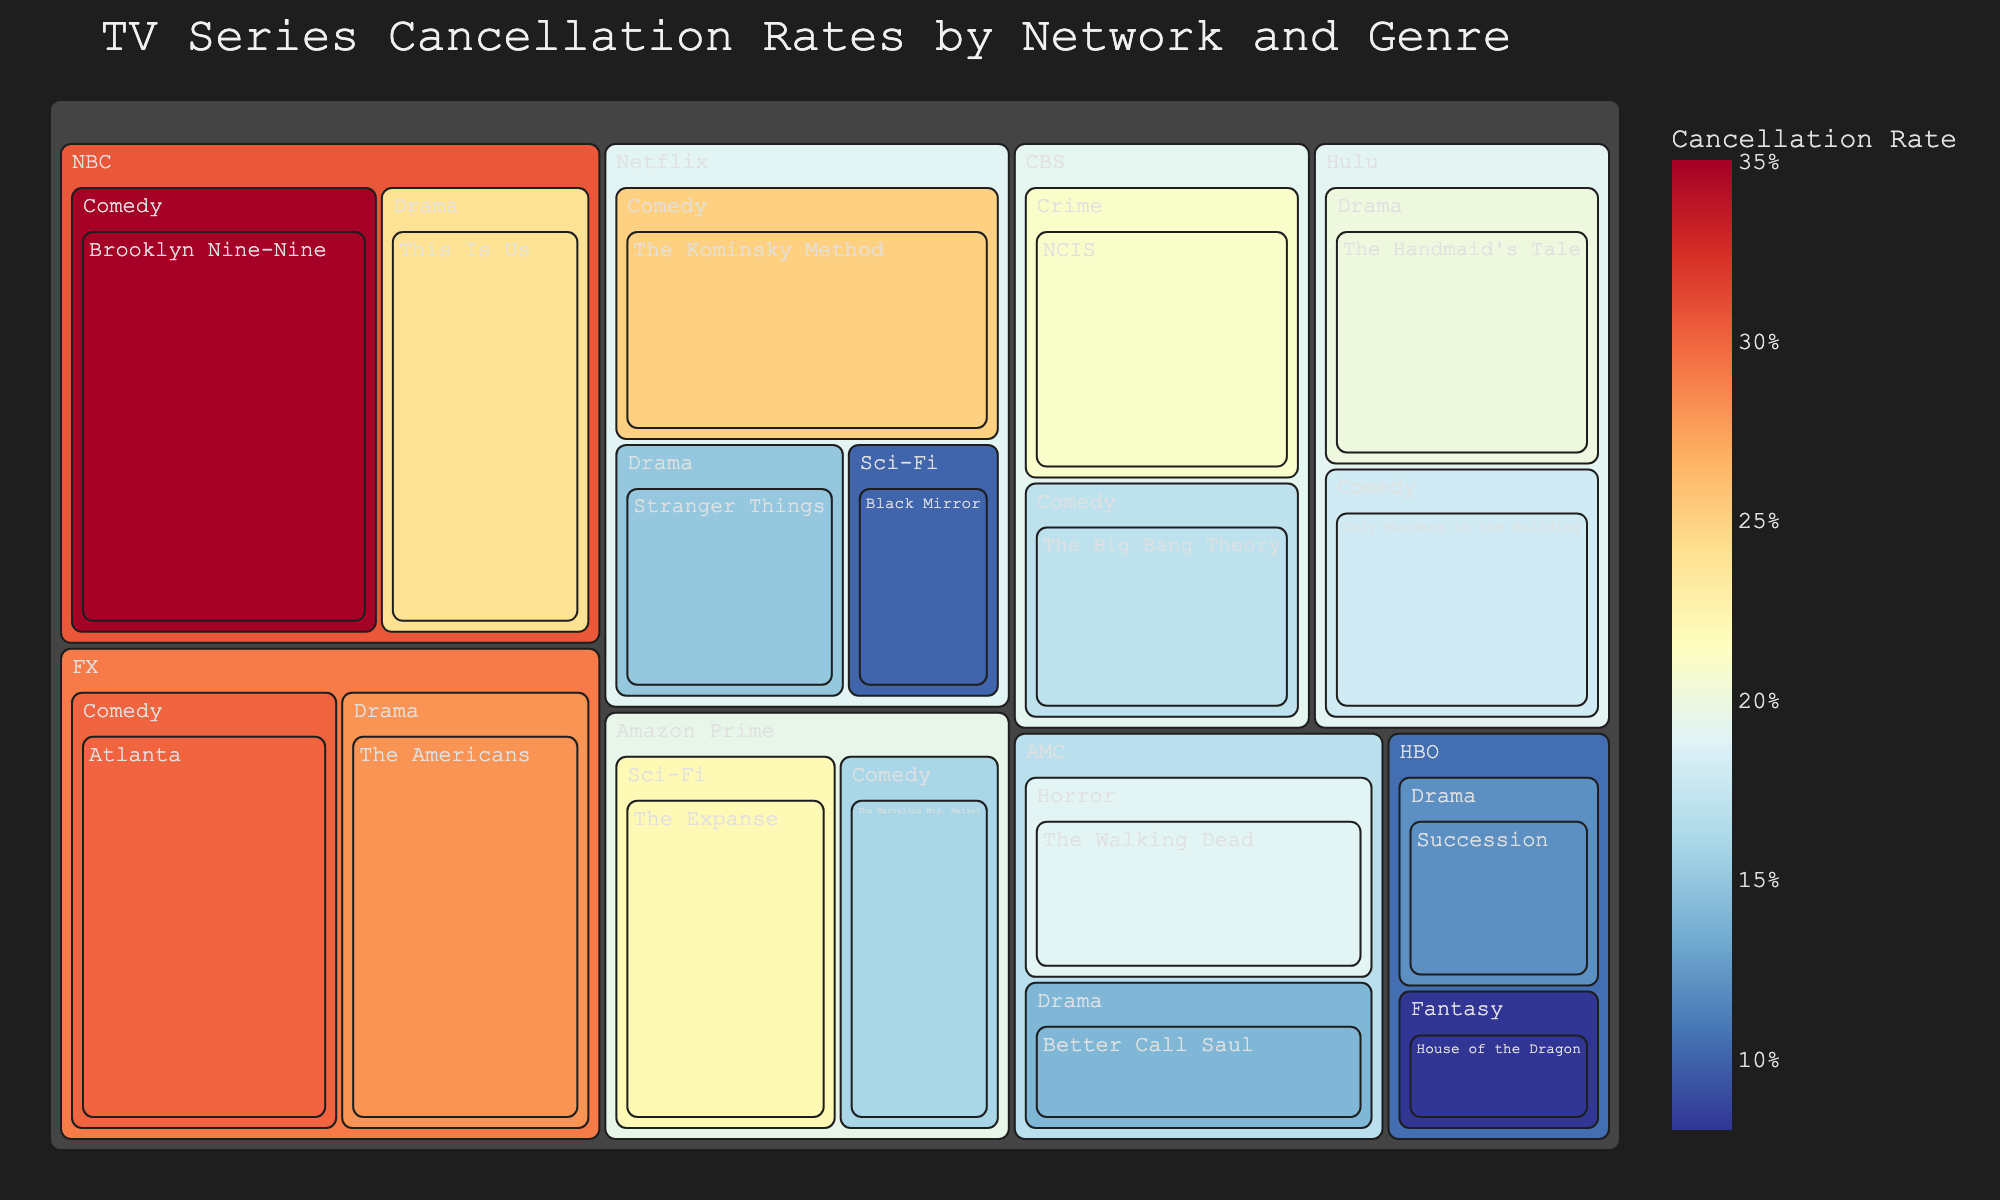What is the title of the figure? The title of the figure is typically the most prominent text and found at the top. It summarizes the content being displayed.
Answer: TV Series Cancellation Rates by Network and Genre Which network has the highest cancellation rate for a comedy series? Scan the treemap for the highest value in the "Comedy" genre and note its parent network.
Answer: NBC How many genres are shown for HBO in the figure? Identify the subcategories under HBO and count how many unique genre labels are present.
Answer: Two Which series has the lowest cancellation rate in the Drama genre? Inspect the Drama genre sections across networks and compare the cancellation rates to find the lowest one.
Answer: Succession Compare Netflix and Hulu in terms of the cancellation rate for comedy series. Which has a higher rate? Look at the comedy cancellation rates for Netflix and Hulu, then determine which one is higher.
Answer: Netflix Does FX have a higher overall cancellation rate for Drama or Comedy series? Compare the cancellation rates for the series under the Drama and Comedy genres in FX and add them up to see which is higher.
Answer: Comedy Is the cancellation rate for Amazon Prime's sci-fi series higher or lower than the cancellation rate for its comedy series? Compare the cancellation rates of "The Expanse" (Sci-Fi) and "The Marvelous Mrs. Maisel" (Comedy) to determine which is higher.
Answer: Higher What is the range of cancellation rates for Drama series across all networks? Note the highest and lowest cancellation rates in the Drama genre across all networks and calculate the range by subtracting the lowest rate from the highest.
Answer: 0.28 - 0.12 Which genre has the widest variability in cancellation rates across all networks? Observe the span of cancellation rates in each genre across networks and find which genre varies the most from the lowest to the highest rate.
Answer: Drama Based on the color scale, which series likely has the closest cancellation rate to 10%? Identify the series with a shade in the color range corresponding to approximately 10% on the color scale, considering the provided color mapping.
Answer: Black Mirror 